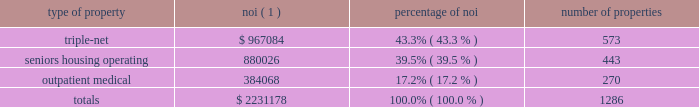Item 7 .
Management 2019s discussion and analysis of financial condition and results of operations the following discussion and analysis is based primarily on the consolidated financial statements of welltower inc .
Presented in conformity with u.s .
Generally accepted accounting principles ( 201cu.s .
Gaap 201d ) for the periods presented and should be read together with the notes thereto contained in this annual report on form 10-k .
Other important factors are identified in 201citem 1 2014 business 201d and 201citem 1a 2014 risk factors 201d above .
Executive summary company overview welltower inc .
( nyse:well ) , an s&p 500 company headquartered in toledo , ohio , is driving the transformation of health care infrastructure .
The company invests with leading seniors housing operators , post- acute providers and health systems to fund the real estate and infrastructure needed to scale innovative care delivery models and improve people 2019s wellness and overall health care experience .
Welltowertm , a real estate investment trust ( 201creit 201d ) , owns interests in properties concentrated in major , high-growth markets in the united states ( 201cu.s . 201d ) , canada and the united kingdom ( 201cu.k . 201d ) , consisting of seniors housing and post-acute communities and outpatient medical properties .
Our capital programs , when combined with comprehensive planning , development and property management services , make us a single-source solution for acquiring , planning , developing , managing , repositioning and monetizing real estate assets .
The table summarizes our consolidated portfolio for the year ended december 31 , 2017 ( dollars in thousands ) : type of property noi ( 1 ) percentage of number of properties .
( 1 ) represents consolidated noi and excludes our share of investments in unconsolidated entities .
Entities in which we have a joint venture with a minority partner are shown at 100% ( 100 % ) of the joint venture amount .
See non-gaap financial measures for additional information and reconciliation .
Business strategy our primary objectives are to protect stockholder capital and enhance stockholder value .
We seek to pay consistent cash dividends to stockholders and create opportunities to increase dividend payments to stockholders as a result of annual increases in net operating income and portfolio growth .
To meet these objectives , we invest across the full spectrum of seniors housing and health care real estate and diversify our investment portfolio by property type , relationship and geographic location .
Substantially all of our revenues are derived from operating lease rentals , resident fees/services , and interest earned on outstanding loans receivable .
These items represent our primary sources of liquidity to fund distributions and depend upon the continued ability of our obligors to make contractual rent and interest payments to us and the profitability of our operating properties .
To the extent that our obligors/partners experience operating difficulties and become unable to generate sufficient cash to make payments or operating distributions to us , there could be a material adverse impact on our consolidated results of operations , liquidity and/or financial condition .
To mitigate this risk , we monitor our investments through a variety of methods determined by the type of property .
Our asset management process for seniors housing properties generally includes review of monthly financial statements and other operating data for each property , review of obligor/ partner creditworthiness , property inspections , and review of covenant compliance relating to licensure , real estate taxes , letters of credit and other collateral .
Our internal property management division manages and monitors the outpatient medical portfolio with a comprehensive process including review of tenant relations .
What percent of total noi is from outpatient medical? 
Computations: (384068 / 2231178)
Answer: 0.17214. 